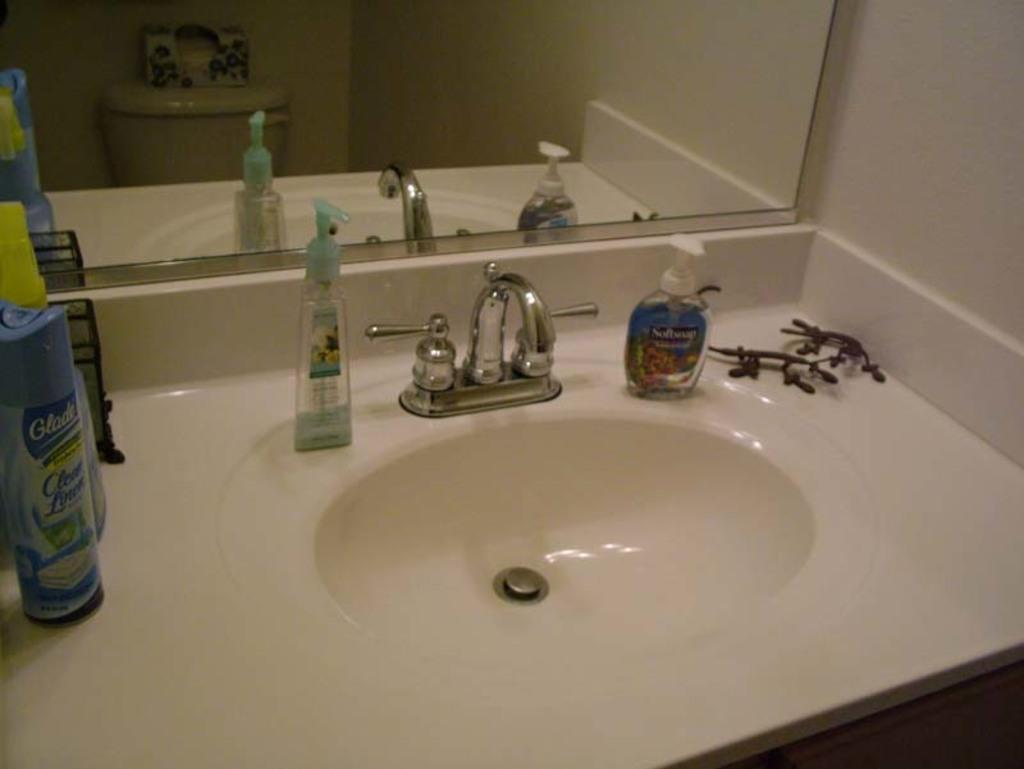What type of objects can be seen in the image? There are bottles in the image. What else is present on the sink in the image? There are other objects on the sink in the image. What can be seen in the background of the image? There is a mirror and a wall in the background of the image. How many cattle are visible in the image? There are no cattle present in the image. What type of glue is being used to attach the mirror to the wall in the image? There is no glue visible in the image, and the method of attaching the mirror to the wall is not mentioned. 